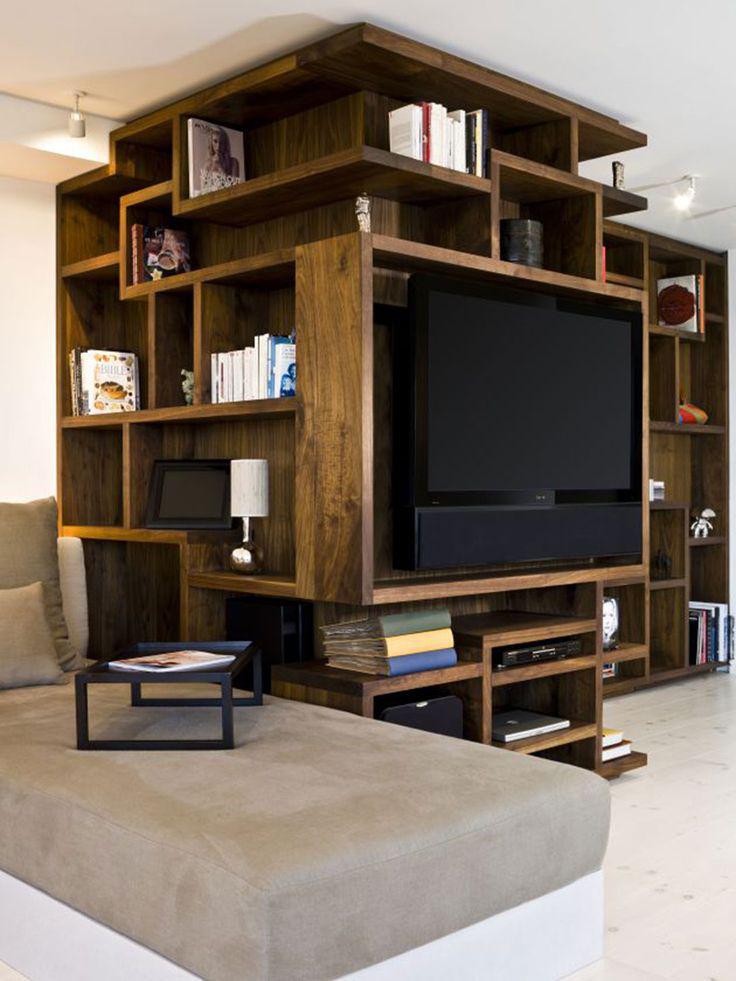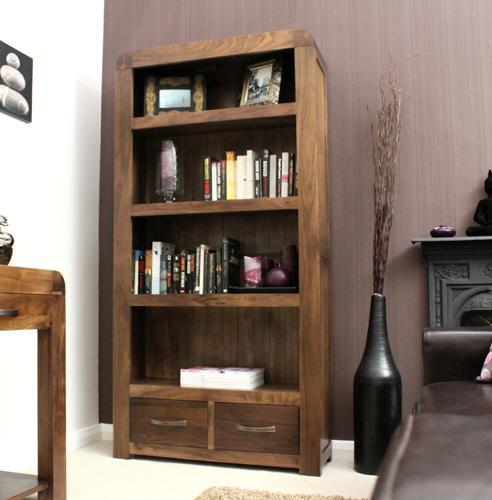The first image is the image on the left, the second image is the image on the right. Evaluate the accuracy of this statement regarding the images: "IN at least one image there is a free floating shelving.". Is it true? Answer yes or no. No. 